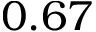Convert formula to latex. <formula><loc_0><loc_0><loc_500><loc_500>0 . 6 7</formula> 